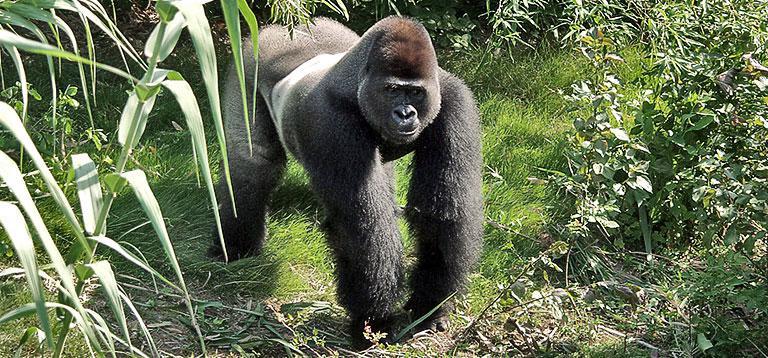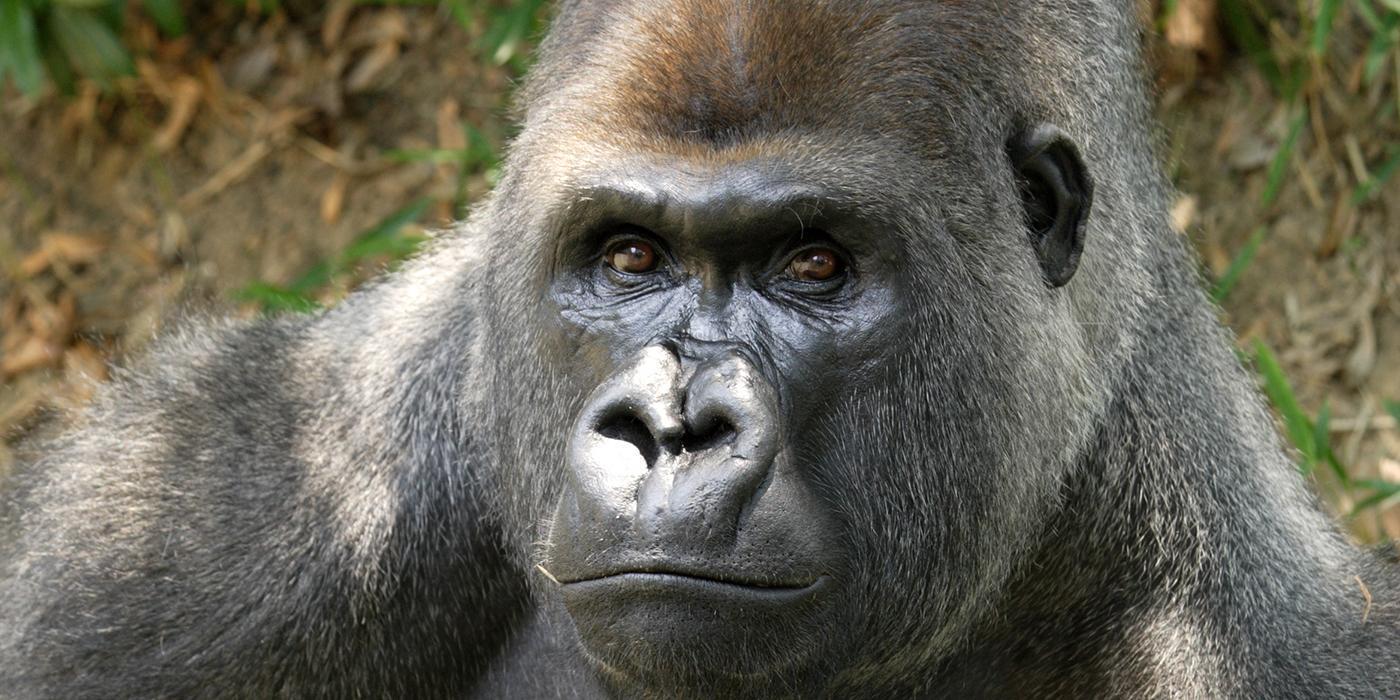The first image is the image on the left, the second image is the image on the right. Evaluate the accuracy of this statement regarding the images: "There are no more than two gorillas.". Is it true? Answer yes or no. Yes. The first image is the image on the left, the second image is the image on the right. Given the left and right images, does the statement "There is one gorilla walking and one that is stationary while facing to the left." hold true? Answer yes or no. Yes. 